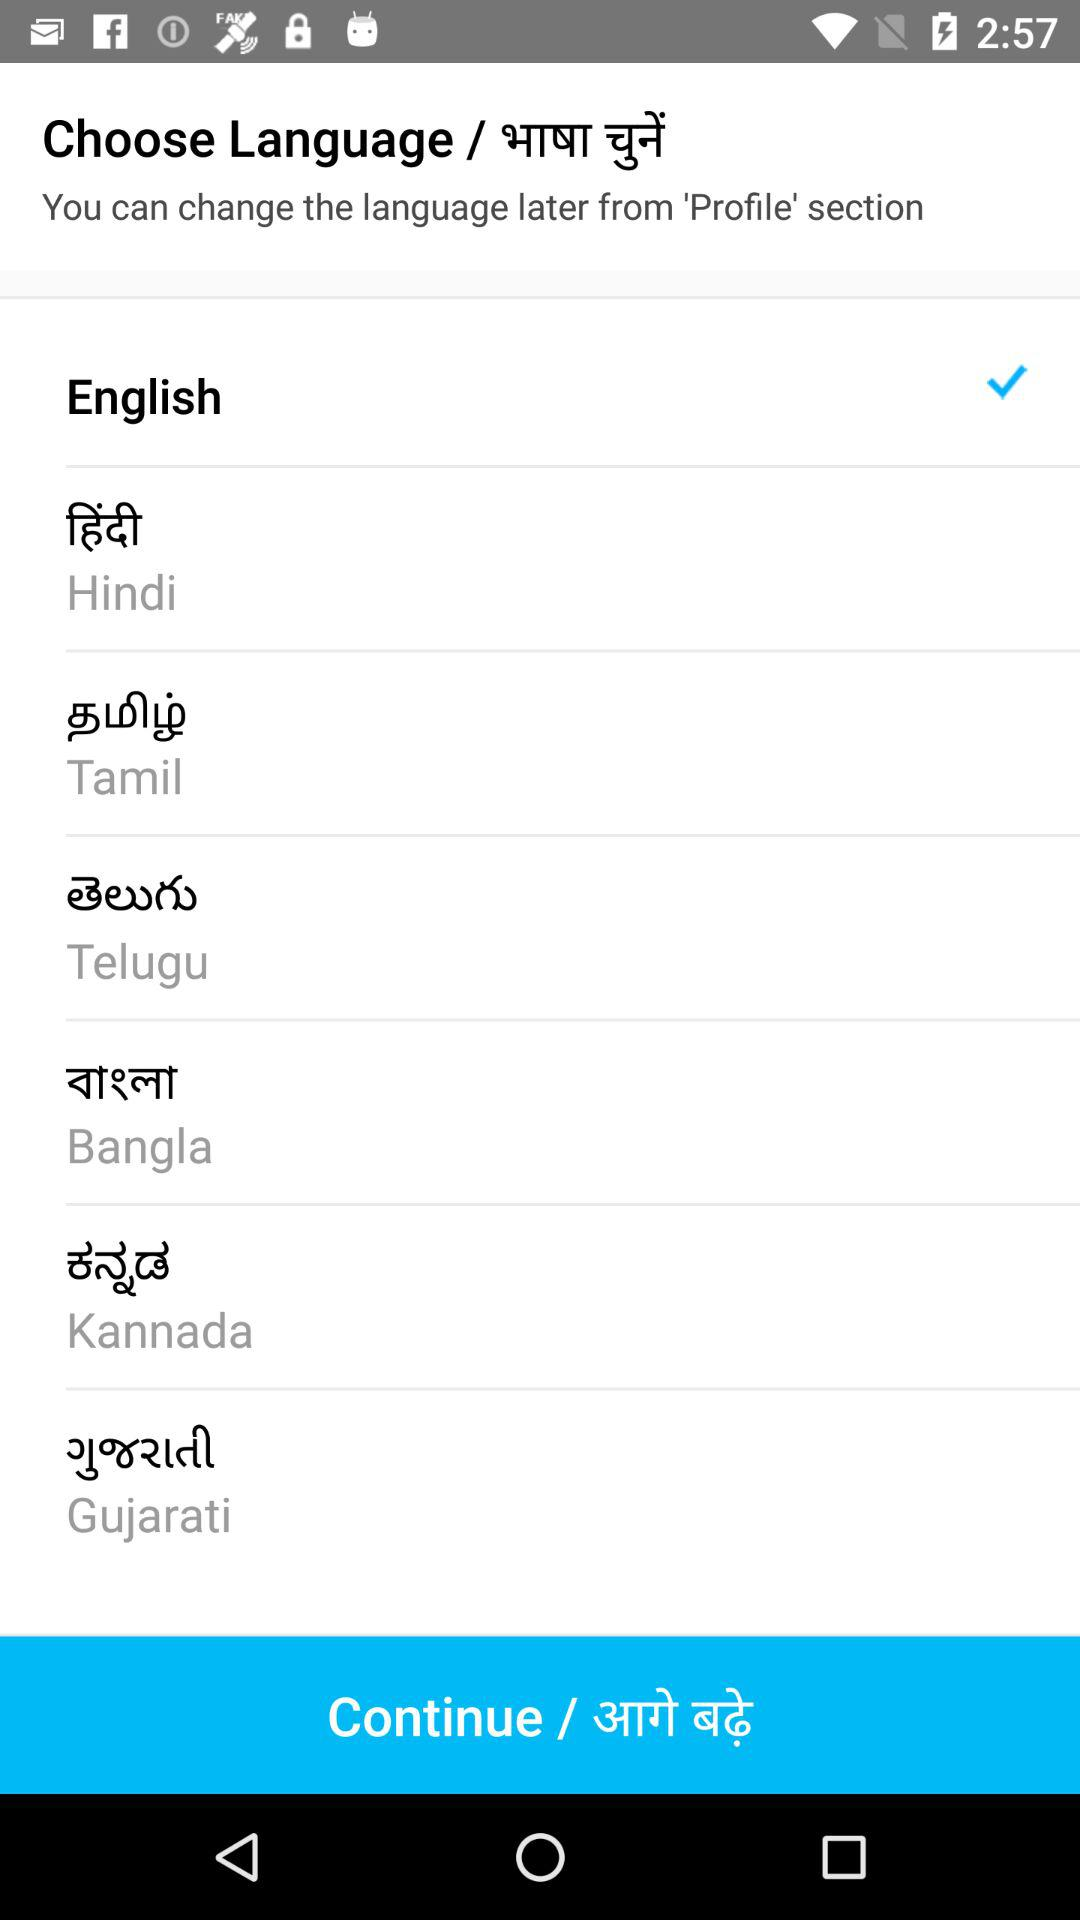Which language is selected? The selected language is English. 